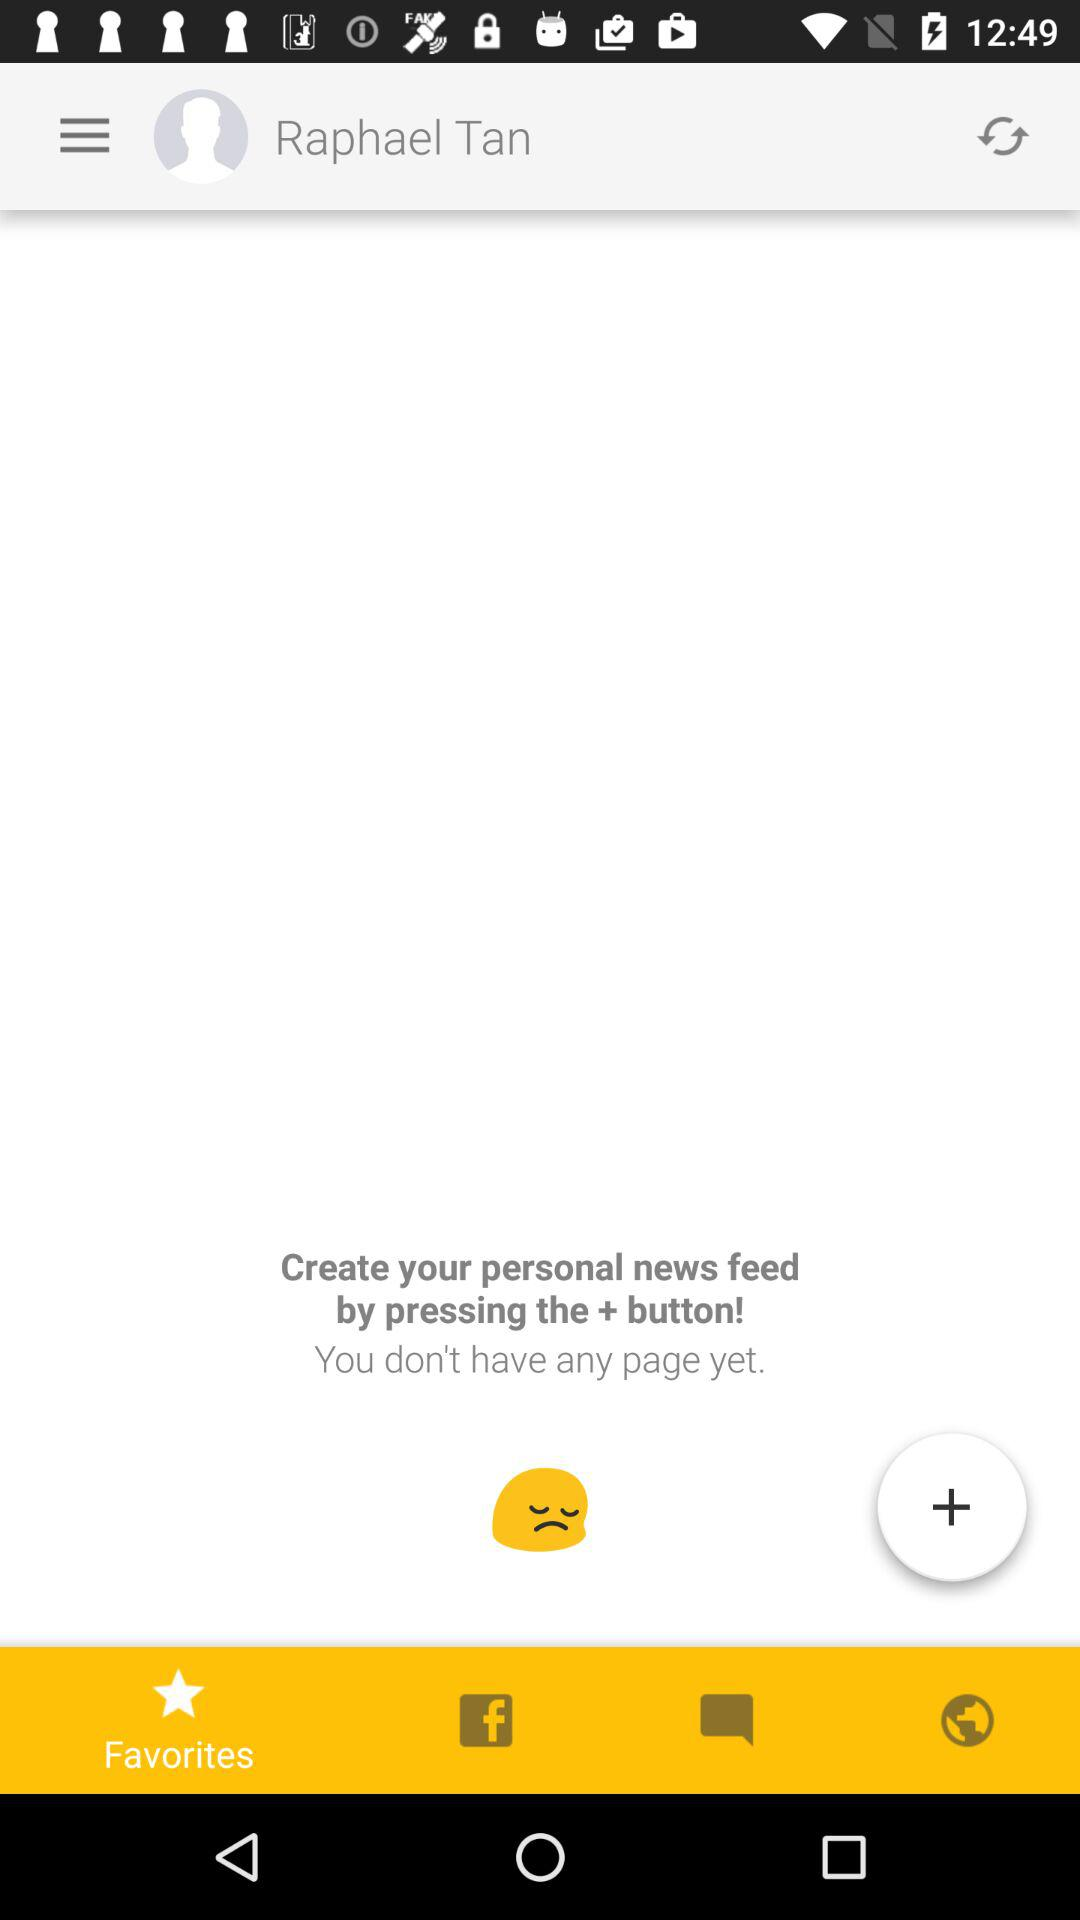What is the user name? The user name is Raphael Tan. 